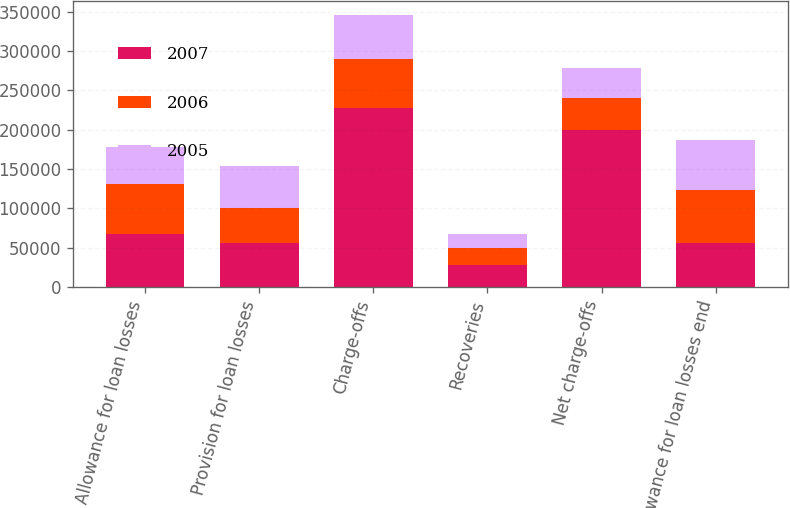Convert chart. <chart><loc_0><loc_0><loc_500><loc_500><stacked_bar_chart><ecel><fcel>Allowance for loan losses<fcel>Provision for loan losses<fcel>Charge-offs<fcel>Recoveries<fcel>Net charge-offs<fcel>Allowance for loan losses end<nl><fcel>2007<fcel>67628<fcel>55431.5<fcel>227679<fcel>28137<fcel>199542<fcel>55431.5<nl><fcel>2006<fcel>63286<fcel>44970<fcel>61843<fcel>21215<fcel>40628<fcel>67628<nl><fcel>2005<fcel>47681<fcel>54016<fcel>56847<fcel>18436<fcel>38411<fcel>63286<nl></chart> 